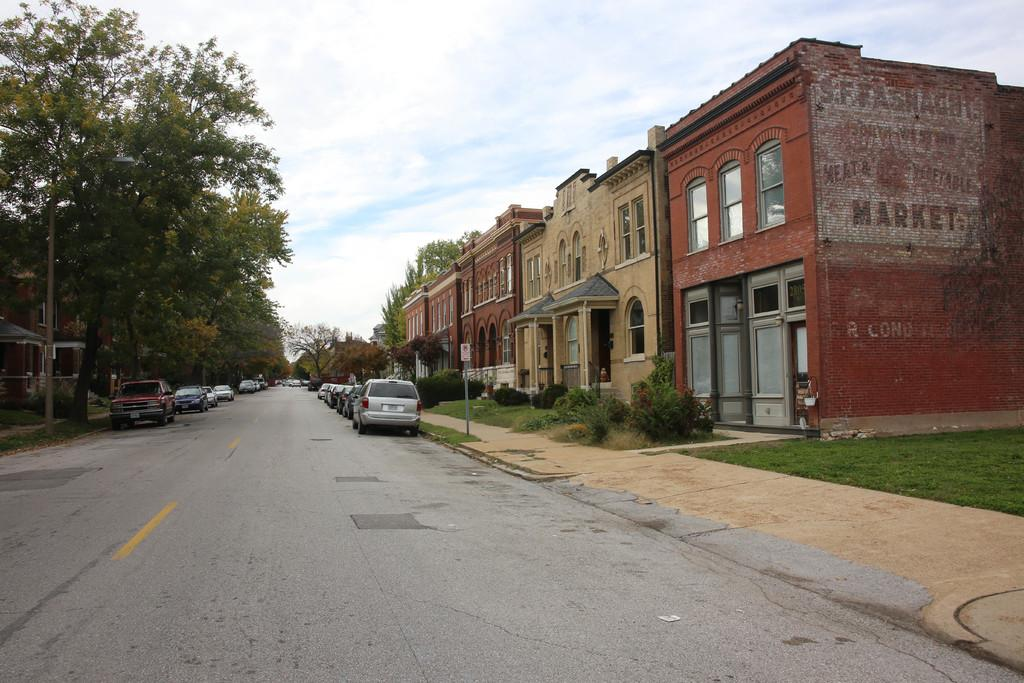What is the main subject of the image? The image depicts a road. What can be seen on the road? There are parked cars on the road. What type of vegetation is on the left side of the road? There are green trees on the left side of the road. What type of structures are on the right side of the road? There are houses on the right side of the road. What is visible at the top of the image? The sky is visible at the top of the image. Where is the toothbrush located in the image? There is no toothbrush present in the image. What type of trouble can be seen happening on the road in the image? There is no trouble or any indication of trouble happening on the road in the image. 